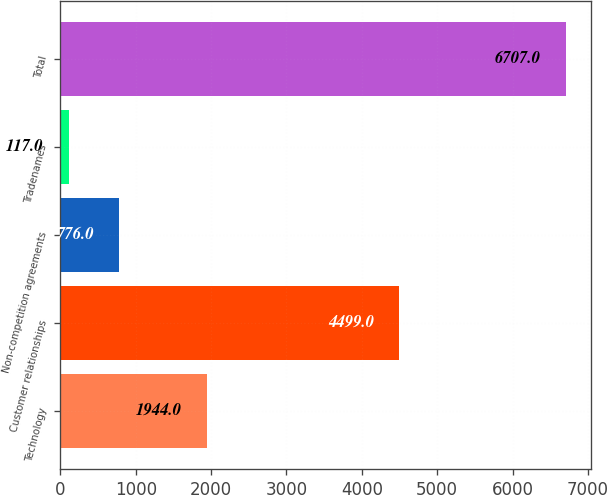Convert chart. <chart><loc_0><loc_0><loc_500><loc_500><bar_chart><fcel>Technology<fcel>Customer relationships<fcel>Non-competition agreements<fcel>Tradenames<fcel>Total<nl><fcel>1944<fcel>4499<fcel>776<fcel>117<fcel>6707<nl></chart> 